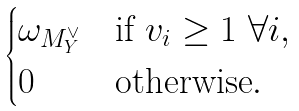<formula> <loc_0><loc_0><loc_500><loc_500>\begin{cases} \omega _ { M _ { Y } ^ { \vee } } & \text {if } v _ { i } \geq 1 \ \forall i , \\ 0 & \text {otherwise} . \end{cases}</formula> 